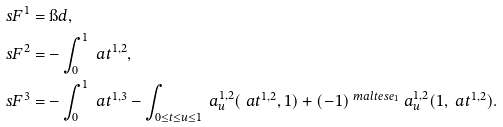<formula> <loc_0><loc_0><loc_500><loc_500>\ s F ^ { 1 } & = \i d , \\ \ s F ^ { 2 } & = - \int _ { 0 } ^ { 1 } \ a t ^ { 1 , 2 } , \\ \ s F ^ { 3 } & = - \int _ { 0 } ^ { 1 } \ a t ^ { 1 , 3 } - \int _ { 0 \leq t \leq u \leq 1 } \ a ^ { 1 , 2 } _ { u } ( \ a t ^ { 1 , 2 } , 1 ) + ( - 1 ) ^ { \ m a l t e s e _ { 1 } } \ a ^ { 1 , 2 } _ { u } ( 1 , \ a t ^ { 1 , 2 } ) .</formula> 